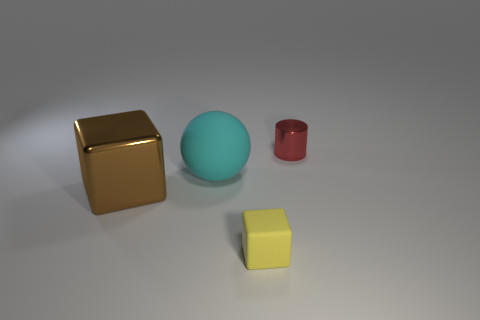What number of objects are large cyan balls or cylinders?
Keep it short and to the point. 2. There is a shiny thing to the left of the red shiny cylinder; is it the same shape as the big rubber thing?
Make the answer very short. No. The thing behind the matte thing left of the small block is what color?
Provide a short and direct response. Red. Is the number of tiny rubber things less than the number of metallic things?
Ensure brevity in your answer.  Yes. Are there any large brown things made of the same material as the cylinder?
Keep it short and to the point. Yes. Is the shape of the small yellow object the same as the metallic object that is to the right of the yellow rubber cube?
Provide a succinct answer. No. There is a small yellow matte object; are there any red metal objects behind it?
Offer a terse response. Yes. What number of large brown things have the same shape as the tiny yellow matte object?
Offer a very short reply. 1. Is the material of the big cube the same as the cube that is on the right side of the big cyan ball?
Give a very brief answer. No. How many brown metallic spheres are there?
Your answer should be very brief. 0. 